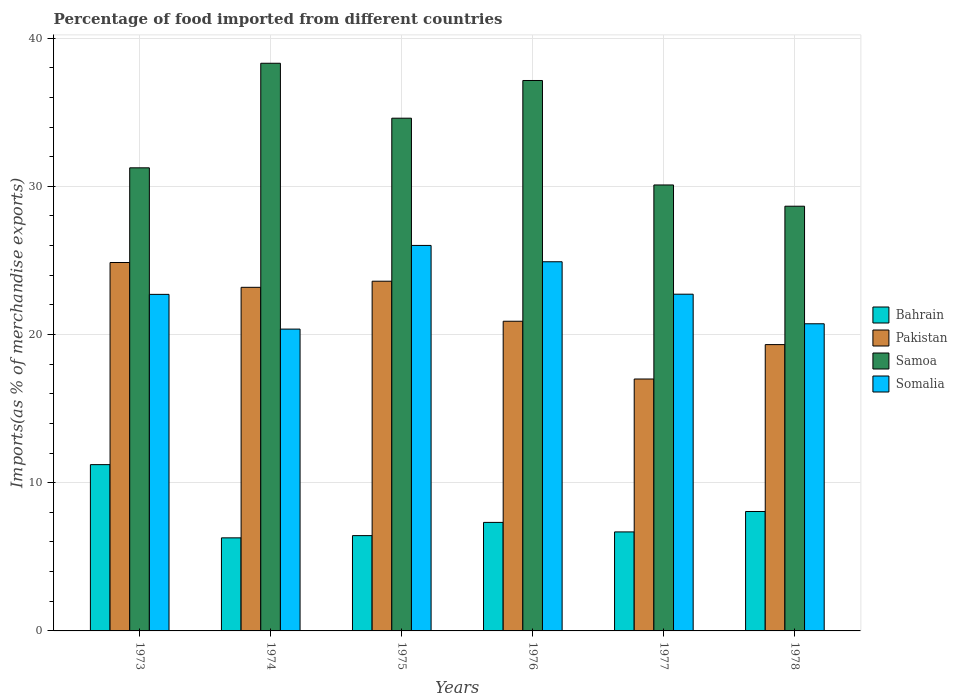How many groups of bars are there?
Offer a terse response. 6. How many bars are there on the 5th tick from the right?
Offer a very short reply. 4. What is the percentage of imports to different countries in Pakistan in 1977?
Make the answer very short. 17. Across all years, what is the maximum percentage of imports to different countries in Bahrain?
Offer a very short reply. 11.22. Across all years, what is the minimum percentage of imports to different countries in Pakistan?
Your answer should be very brief. 17. In which year was the percentage of imports to different countries in Samoa maximum?
Make the answer very short. 1974. In which year was the percentage of imports to different countries in Bahrain minimum?
Your response must be concise. 1974. What is the total percentage of imports to different countries in Somalia in the graph?
Provide a succinct answer. 137.44. What is the difference between the percentage of imports to different countries in Bahrain in 1977 and that in 1978?
Your answer should be very brief. -1.38. What is the difference between the percentage of imports to different countries in Samoa in 1974 and the percentage of imports to different countries in Pakistan in 1978?
Provide a succinct answer. 18.98. What is the average percentage of imports to different countries in Somalia per year?
Offer a very short reply. 22.91. In the year 1973, what is the difference between the percentage of imports to different countries in Pakistan and percentage of imports to different countries in Samoa?
Your answer should be very brief. -6.39. In how many years, is the percentage of imports to different countries in Bahrain greater than 16 %?
Make the answer very short. 0. What is the ratio of the percentage of imports to different countries in Somalia in 1974 to that in 1976?
Offer a very short reply. 0.82. What is the difference between the highest and the second highest percentage of imports to different countries in Bahrain?
Offer a terse response. 3.16. What is the difference between the highest and the lowest percentage of imports to different countries in Pakistan?
Ensure brevity in your answer.  7.86. In how many years, is the percentage of imports to different countries in Bahrain greater than the average percentage of imports to different countries in Bahrain taken over all years?
Make the answer very short. 2. Is it the case that in every year, the sum of the percentage of imports to different countries in Pakistan and percentage of imports to different countries in Somalia is greater than the sum of percentage of imports to different countries in Samoa and percentage of imports to different countries in Bahrain?
Offer a very short reply. No. What does the 3rd bar from the left in 1976 represents?
Offer a very short reply. Samoa. What does the 1st bar from the right in 1976 represents?
Your answer should be very brief. Somalia. How many bars are there?
Your response must be concise. 24. Are all the bars in the graph horizontal?
Offer a terse response. No. How many years are there in the graph?
Your answer should be compact. 6. What is the difference between two consecutive major ticks on the Y-axis?
Your answer should be compact. 10. Does the graph contain any zero values?
Offer a terse response. No. Does the graph contain grids?
Give a very brief answer. Yes. How many legend labels are there?
Ensure brevity in your answer.  4. How are the legend labels stacked?
Your response must be concise. Vertical. What is the title of the graph?
Ensure brevity in your answer.  Percentage of food imported from different countries. What is the label or title of the X-axis?
Offer a terse response. Years. What is the label or title of the Y-axis?
Offer a terse response. Imports(as % of merchandise exports). What is the Imports(as % of merchandise exports) in Bahrain in 1973?
Provide a short and direct response. 11.22. What is the Imports(as % of merchandise exports) in Pakistan in 1973?
Your response must be concise. 24.86. What is the Imports(as % of merchandise exports) in Samoa in 1973?
Offer a very short reply. 31.25. What is the Imports(as % of merchandise exports) in Somalia in 1973?
Ensure brevity in your answer.  22.71. What is the Imports(as % of merchandise exports) in Bahrain in 1974?
Give a very brief answer. 6.28. What is the Imports(as % of merchandise exports) in Pakistan in 1974?
Your response must be concise. 23.18. What is the Imports(as % of merchandise exports) of Samoa in 1974?
Your response must be concise. 38.3. What is the Imports(as % of merchandise exports) in Somalia in 1974?
Keep it short and to the point. 20.37. What is the Imports(as % of merchandise exports) of Bahrain in 1975?
Offer a very short reply. 6.43. What is the Imports(as % of merchandise exports) in Pakistan in 1975?
Offer a very short reply. 23.6. What is the Imports(as % of merchandise exports) of Samoa in 1975?
Provide a succinct answer. 34.6. What is the Imports(as % of merchandise exports) of Somalia in 1975?
Provide a short and direct response. 26.01. What is the Imports(as % of merchandise exports) of Bahrain in 1976?
Keep it short and to the point. 7.32. What is the Imports(as % of merchandise exports) in Pakistan in 1976?
Provide a succinct answer. 20.9. What is the Imports(as % of merchandise exports) of Samoa in 1976?
Provide a succinct answer. 37.14. What is the Imports(as % of merchandise exports) of Somalia in 1976?
Offer a very short reply. 24.91. What is the Imports(as % of merchandise exports) in Bahrain in 1977?
Offer a very short reply. 6.68. What is the Imports(as % of merchandise exports) of Pakistan in 1977?
Your answer should be very brief. 17. What is the Imports(as % of merchandise exports) in Samoa in 1977?
Your answer should be compact. 30.09. What is the Imports(as % of merchandise exports) of Somalia in 1977?
Provide a short and direct response. 22.72. What is the Imports(as % of merchandise exports) of Bahrain in 1978?
Offer a terse response. 8.06. What is the Imports(as % of merchandise exports) in Pakistan in 1978?
Provide a short and direct response. 19.32. What is the Imports(as % of merchandise exports) of Samoa in 1978?
Offer a terse response. 28.66. What is the Imports(as % of merchandise exports) in Somalia in 1978?
Keep it short and to the point. 20.72. Across all years, what is the maximum Imports(as % of merchandise exports) of Bahrain?
Offer a very short reply. 11.22. Across all years, what is the maximum Imports(as % of merchandise exports) in Pakistan?
Keep it short and to the point. 24.86. Across all years, what is the maximum Imports(as % of merchandise exports) of Samoa?
Ensure brevity in your answer.  38.3. Across all years, what is the maximum Imports(as % of merchandise exports) in Somalia?
Offer a very short reply. 26.01. Across all years, what is the minimum Imports(as % of merchandise exports) in Bahrain?
Provide a succinct answer. 6.28. Across all years, what is the minimum Imports(as % of merchandise exports) in Pakistan?
Provide a succinct answer. 17. Across all years, what is the minimum Imports(as % of merchandise exports) of Samoa?
Your answer should be compact. 28.66. Across all years, what is the minimum Imports(as % of merchandise exports) in Somalia?
Your answer should be very brief. 20.37. What is the total Imports(as % of merchandise exports) of Bahrain in the graph?
Offer a terse response. 45.99. What is the total Imports(as % of merchandise exports) of Pakistan in the graph?
Provide a short and direct response. 128.85. What is the total Imports(as % of merchandise exports) of Samoa in the graph?
Offer a very short reply. 200.04. What is the total Imports(as % of merchandise exports) of Somalia in the graph?
Your answer should be compact. 137.44. What is the difference between the Imports(as % of merchandise exports) in Bahrain in 1973 and that in 1974?
Ensure brevity in your answer.  4.94. What is the difference between the Imports(as % of merchandise exports) of Pakistan in 1973 and that in 1974?
Give a very brief answer. 1.67. What is the difference between the Imports(as % of merchandise exports) in Samoa in 1973 and that in 1974?
Your response must be concise. -7.06. What is the difference between the Imports(as % of merchandise exports) in Somalia in 1973 and that in 1974?
Provide a succinct answer. 2.34. What is the difference between the Imports(as % of merchandise exports) in Bahrain in 1973 and that in 1975?
Provide a short and direct response. 4.79. What is the difference between the Imports(as % of merchandise exports) in Pakistan in 1973 and that in 1975?
Offer a terse response. 1.26. What is the difference between the Imports(as % of merchandise exports) in Samoa in 1973 and that in 1975?
Provide a succinct answer. -3.35. What is the difference between the Imports(as % of merchandise exports) in Somalia in 1973 and that in 1975?
Provide a short and direct response. -3.3. What is the difference between the Imports(as % of merchandise exports) in Bahrain in 1973 and that in 1976?
Ensure brevity in your answer.  3.9. What is the difference between the Imports(as % of merchandise exports) in Pakistan in 1973 and that in 1976?
Your answer should be very brief. 3.96. What is the difference between the Imports(as % of merchandise exports) of Samoa in 1973 and that in 1976?
Keep it short and to the point. -5.89. What is the difference between the Imports(as % of merchandise exports) of Somalia in 1973 and that in 1976?
Offer a terse response. -2.2. What is the difference between the Imports(as % of merchandise exports) of Bahrain in 1973 and that in 1977?
Provide a short and direct response. 4.54. What is the difference between the Imports(as % of merchandise exports) in Pakistan in 1973 and that in 1977?
Give a very brief answer. 7.86. What is the difference between the Imports(as % of merchandise exports) of Samoa in 1973 and that in 1977?
Keep it short and to the point. 1.16. What is the difference between the Imports(as % of merchandise exports) of Somalia in 1973 and that in 1977?
Your answer should be very brief. -0.01. What is the difference between the Imports(as % of merchandise exports) of Bahrain in 1973 and that in 1978?
Give a very brief answer. 3.16. What is the difference between the Imports(as % of merchandise exports) of Pakistan in 1973 and that in 1978?
Your answer should be very brief. 5.54. What is the difference between the Imports(as % of merchandise exports) in Samoa in 1973 and that in 1978?
Your answer should be very brief. 2.59. What is the difference between the Imports(as % of merchandise exports) in Somalia in 1973 and that in 1978?
Offer a very short reply. 1.98. What is the difference between the Imports(as % of merchandise exports) of Bahrain in 1974 and that in 1975?
Ensure brevity in your answer.  -0.15. What is the difference between the Imports(as % of merchandise exports) of Pakistan in 1974 and that in 1975?
Provide a succinct answer. -0.41. What is the difference between the Imports(as % of merchandise exports) of Samoa in 1974 and that in 1975?
Offer a very short reply. 3.71. What is the difference between the Imports(as % of merchandise exports) of Somalia in 1974 and that in 1975?
Your answer should be very brief. -5.65. What is the difference between the Imports(as % of merchandise exports) in Bahrain in 1974 and that in 1976?
Your response must be concise. -1.04. What is the difference between the Imports(as % of merchandise exports) in Pakistan in 1974 and that in 1976?
Keep it short and to the point. 2.29. What is the difference between the Imports(as % of merchandise exports) of Samoa in 1974 and that in 1976?
Keep it short and to the point. 1.16. What is the difference between the Imports(as % of merchandise exports) in Somalia in 1974 and that in 1976?
Offer a very short reply. -4.54. What is the difference between the Imports(as % of merchandise exports) of Bahrain in 1974 and that in 1977?
Offer a very short reply. -0.4. What is the difference between the Imports(as % of merchandise exports) in Pakistan in 1974 and that in 1977?
Your response must be concise. 6.19. What is the difference between the Imports(as % of merchandise exports) of Samoa in 1974 and that in 1977?
Make the answer very short. 8.21. What is the difference between the Imports(as % of merchandise exports) in Somalia in 1974 and that in 1977?
Provide a short and direct response. -2.36. What is the difference between the Imports(as % of merchandise exports) in Bahrain in 1974 and that in 1978?
Ensure brevity in your answer.  -1.78. What is the difference between the Imports(as % of merchandise exports) in Pakistan in 1974 and that in 1978?
Offer a very short reply. 3.87. What is the difference between the Imports(as % of merchandise exports) of Samoa in 1974 and that in 1978?
Offer a very short reply. 9.65. What is the difference between the Imports(as % of merchandise exports) of Somalia in 1974 and that in 1978?
Make the answer very short. -0.36. What is the difference between the Imports(as % of merchandise exports) in Bahrain in 1975 and that in 1976?
Offer a very short reply. -0.89. What is the difference between the Imports(as % of merchandise exports) in Pakistan in 1975 and that in 1976?
Keep it short and to the point. 2.7. What is the difference between the Imports(as % of merchandise exports) in Samoa in 1975 and that in 1976?
Keep it short and to the point. -2.54. What is the difference between the Imports(as % of merchandise exports) in Somalia in 1975 and that in 1976?
Provide a short and direct response. 1.1. What is the difference between the Imports(as % of merchandise exports) of Bahrain in 1975 and that in 1977?
Offer a very short reply. -0.25. What is the difference between the Imports(as % of merchandise exports) in Pakistan in 1975 and that in 1977?
Make the answer very short. 6.6. What is the difference between the Imports(as % of merchandise exports) in Samoa in 1975 and that in 1977?
Make the answer very short. 4.5. What is the difference between the Imports(as % of merchandise exports) in Somalia in 1975 and that in 1977?
Make the answer very short. 3.29. What is the difference between the Imports(as % of merchandise exports) of Bahrain in 1975 and that in 1978?
Your answer should be very brief. -1.63. What is the difference between the Imports(as % of merchandise exports) in Pakistan in 1975 and that in 1978?
Offer a terse response. 4.28. What is the difference between the Imports(as % of merchandise exports) of Samoa in 1975 and that in 1978?
Ensure brevity in your answer.  5.94. What is the difference between the Imports(as % of merchandise exports) in Somalia in 1975 and that in 1978?
Ensure brevity in your answer.  5.29. What is the difference between the Imports(as % of merchandise exports) of Bahrain in 1976 and that in 1977?
Your answer should be compact. 0.64. What is the difference between the Imports(as % of merchandise exports) in Pakistan in 1976 and that in 1977?
Offer a terse response. 3.9. What is the difference between the Imports(as % of merchandise exports) of Samoa in 1976 and that in 1977?
Offer a very short reply. 7.05. What is the difference between the Imports(as % of merchandise exports) in Somalia in 1976 and that in 1977?
Ensure brevity in your answer.  2.19. What is the difference between the Imports(as % of merchandise exports) of Bahrain in 1976 and that in 1978?
Provide a short and direct response. -0.74. What is the difference between the Imports(as % of merchandise exports) in Pakistan in 1976 and that in 1978?
Your answer should be very brief. 1.58. What is the difference between the Imports(as % of merchandise exports) in Samoa in 1976 and that in 1978?
Your answer should be compact. 8.48. What is the difference between the Imports(as % of merchandise exports) of Somalia in 1976 and that in 1978?
Offer a terse response. 4.18. What is the difference between the Imports(as % of merchandise exports) in Bahrain in 1977 and that in 1978?
Provide a short and direct response. -1.38. What is the difference between the Imports(as % of merchandise exports) in Pakistan in 1977 and that in 1978?
Offer a terse response. -2.32. What is the difference between the Imports(as % of merchandise exports) in Samoa in 1977 and that in 1978?
Your answer should be very brief. 1.43. What is the difference between the Imports(as % of merchandise exports) of Somalia in 1977 and that in 1978?
Ensure brevity in your answer.  2. What is the difference between the Imports(as % of merchandise exports) in Bahrain in 1973 and the Imports(as % of merchandise exports) in Pakistan in 1974?
Ensure brevity in your answer.  -11.96. What is the difference between the Imports(as % of merchandise exports) in Bahrain in 1973 and the Imports(as % of merchandise exports) in Samoa in 1974?
Give a very brief answer. -27.08. What is the difference between the Imports(as % of merchandise exports) in Bahrain in 1973 and the Imports(as % of merchandise exports) in Somalia in 1974?
Make the answer very short. -9.14. What is the difference between the Imports(as % of merchandise exports) of Pakistan in 1973 and the Imports(as % of merchandise exports) of Samoa in 1974?
Give a very brief answer. -13.44. What is the difference between the Imports(as % of merchandise exports) in Pakistan in 1973 and the Imports(as % of merchandise exports) in Somalia in 1974?
Offer a very short reply. 4.49. What is the difference between the Imports(as % of merchandise exports) in Samoa in 1973 and the Imports(as % of merchandise exports) in Somalia in 1974?
Your answer should be compact. 10.88. What is the difference between the Imports(as % of merchandise exports) in Bahrain in 1973 and the Imports(as % of merchandise exports) in Pakistan in 1975?
Offer a terse response. -12.38. What is the difference between the Imports(as % of merchandise exports) of Bahrain in 1973 and the Imports(as % of merchandise exports) of Samoa in 1975?
Ensure brevity in your answer.  -23.37. What is the difference between the Imports(as % of merchandise exports) in Bahrain in 1973 and the Imports(as % of merchandise exports) in Somalia in 1975?
Offer a terse response. -14.79. What is the difference between the Imports(as % of merchandise exports) of Pakistan in 1973 and the Imports(as % of merchandise exports) of Samoa in 1975?
Your answer should be very brief. -9.74. What is the difference between the Imports(as % of merchandise exports) of Pakistan in 1973 and the Imports(as % of merchandise exports) of Somalia in 1975?
Your response must be concise. -1.15. What is the difference between the Imports(as % of merchandise exports) of Samoa in 1973 and the Imports(as % of merchandise exports) of Somalia in 1975?
Offer a very short reply. 5.24. What is the difference between the Imports(as % of merchandise exports) in Bahrain in 1973 and the Imports(as % of merchandise exports) in Pakistan in 1976?
Your answer should be compact. -9.67. What is the difference between the Imports(as % of merchandise exports) in Bahrain in 1973 and the Imports(as % of merchandise exports) in Samoa in 1976?
Keep it short and to the point. -25.92. What is the difference between the Imports(as % of merchandise exports) in Bahrain in 1973 and the Imports(as % of merchandise exports) in Somalia in 1976?
Offer a very short reply. -13.69. What is the difference between the Imports(as % of merchandise exports) of Pakistan in 1973 and the Imports(as % of merchandise exports) of Samoa in 1976?
Offer a very short reply. -12.28. What is the difference between the Imports(as % of merchandise exports) of Pakistan in 1973 and the Imports(as % of merchandise exports) of Somalia in 1976?
Offer a terse response. -0.05. What is the difference between the Imports(as % of merchandise exports) in Samoa in 1973 and the Imports(as % of merchandise exports) in Somalia in 1976?
Offer a terse response. 6.34. What is the difference between the Imports(as % of merchandise exports) in Bahrain in 1973 and the Imports(as % of merchandise exports) in Pakistan in 1977?
Offer a very short reply. -5.78. What is the difference between the Imports(as % of merchandise exports) of Bahrain in 1973 and the Imports(as % of merchandise exports) of Samoa in 1977?
Ensure brevity in your answer.  -18.87. What is the difference between the Imports(as % of merchandise exports) of Bahrain in 1973 and the Imports(as % of merchandise exports) of Somalia in 1977?
Your response must be concise. -11.5. What is the difference between the Imports(as % of merchandise exports) in Pakistan in 1973 and the Imports(as % of merchandise exports) in Samoa in 1977?
Offer a very short reply. -5.23. What is the difference between the Imports(as % of merchandise exports) in Pakistan in 1973 and the Imports(as % of merchandise exports) in Somalia in 1977?
Keep it short and to the point. 2.14. What is the difference between the Imports(as % of merchandise exports) of Samoa in 1973 and the Imports(as % of merchandise exports) of Somalia in 1977?
Provide a succinct answer. 8.53. What is the difference between the Imports(as % of merchandise exports) of Bahrain in 1973 and the Imports(as % of merchandise exports) of Pakistan in 1978?
Your answer should be compact. -8.1. What is the difference between the Imports(as % of merchandise exports) in Bahrain in 1973 and the Imports(as % of merchandise exports) in Samoa in 1978?
Your answer should be very brief. -17.44. What is the difference between the Imports(as % of merchandise exports) of Bahrain in 1973 and the Imports(as % of merchandise exports) of Somalia in 1978?
Your response must be concise. -9.5. What is the difference between the Imports(as % of merchandise exports) of Pakistan in 1973 and the Imports(as % of merchandise exports) of Samoa in 1978?
Provide a succinct answer. -3.8. What is the difference between the Imports(as % of merchandise exports) of Pakistan in 1973 and the Imports(as % of merchandise exports) of Somalia in 1978?
Provide a short and direct response. 4.13. What is the difference between the Imports(as % of merchandise exports) in Samoa in 1973 and the Imports(as % of merchandise exports) in Somalia in 1978?
Keep it short and to the point. 10.52. What is the difference between the Imports(as % of merchandise exports) in Bahrain in 1974 and the Imports(as % of merchandise exports) in Pakistan in 1975?
Your answer should be very brief. -17.32. What is the difference between the Imports(as % of merchandise exports) of Bahrain in 1974 and the Imports(as % of merchandise exports) of Samoa in 1975?
Ensure brevity in your answer.  -28.32. What is the difference between the Imports(as % of merchandise exports) in Bahrain in 1974 and the Imports(as % of merchandise exports) in Somalia in 1975?
Ensure brevity in your answer.  -19.73. What is the difference between the Imports(as % of merchandise exports) in Pakistan in 1974 and the Imports(as % of merchandise exports) in Samoa in 1975?
Your answer should be very brief. -11.41. What is the difference between the Imports(as % of merchandise exports) of Pakistan in 1974 and the Imports(as % of merchandise exports) of Somalia in 1975?
Offer a terse response. -2.83. What is the difference between the Imports(as % of merchandise exports) in Samoa in 1974 and the Imports(as % of merchandise exports) in Somalia in 1975?
Ensure brevity in your answer.  12.29. What is the difference between the Imports(as % of merchandise exports) of Bahrain in 1974 and the Imports(as % of merchandise exports) of Pakistan in 1976?
Keep it short and to the point. -14.62. What is the difference between the Imports(as % of merchandise exports) in Bahrain in 1974 and the Imports(as % of merchandise exports) in Samoa in 1976?
Ensure brevity in your answer.  -30.86. What is the difference between the Imports(as % of merchandise exports) in Bahrain in 1974 and the Imports(as % of merchandise exports) in Somalia in 1976?
Offer a very short reply. -18.63. What is the difference between the Imports(as % of merchandise exports) of Pakistan in 1974 and the Imports(as % of merchandise exports) of Samoa in 1976?
Provide a succinct answer. -13.96. What is the difference between the Imports(as % of merchandise exports) in Pakistan in 1974 and the Imports(as % of merchandise exports) in Somalia in 1976?
Give a very brief answer. -1.72. What is the difference between the Imports(as % of merchandise exports) in Samoa in 1974 and the Imports(as % of merchandise exports) in Somalia in 1976?
Your answer should be very brief. 13.39. What is the difference between the Imports(as % of merchandise exports) in Bahrain in 1974 and the Imports(as % of merchandise exports) in Pakistan in 1977?
Provide a short and direct response. -10.72. What is the difference between the Imports(as % of merchandise exports) of Bahrain in 1974 and the Imports(as % of merchandise exports) of Samoa in 1977?
Provide a succinct answer. -23.81. What is the difference between the Imports(as % of merchandise exports) in Bahrain in 1974 and the Imports(as % of merchandise exports) in Somalia in 1977?
Make the answer very short. -16.44. What is the difference between the Imports(as % of merchandise exports) of Pakistan in 1974 and the Imports(as % of merchandise exports) of Samoa in 1977?
Your answer should be very brief. -6.91. What is the difference between the Imports(as % of merchandise exports) of Pakistan in 1974 and the Imports(as % of merchandise exports) of Somalia in 1977?
Offer a terse response. 0.46. What is the difference between the Imports(as % of merchandise exports) of Samoa in 1974 and the Imports(as % of merchandise exports) of Somalia in 1977?
Provide a short and direct response. 15.58. What is the difference between the Imports(as % of merchandise exports) in Bahrain in 1974 and the Imports(as % of merchandise exports) in Pakistan in 1978?
Offer a terse response. -13.04. What is the difference between the Imports(as % of merchandise exports) of Bahrain in 1974 and the Imports(as % of merchandise exports) of Samoa in 1978?
Your answer should be compact. -22.38. What is the difference between the Imports(as % of merchandise exports) of Bahrain in 1974 and the Imports(as % of merchandise exports) of Somalia in 1978?
Ensure brevity in your answer.  -14.45. What is the difference between the Imports(as % of merchandise exports) in Pakistan in 1974 and the Imports(as % of merchandise exports) in Samoa in 1978?
Make the answer very short. -5.47. What is the difference between the Imports(as % of merchandise exports) in Pakistan in 1974 and the Imports(as % of merchandise exports) in Somalia in 1978?
Ensure brevity in your answer.  2.46. What is the difference between the Imports(as % of merchandise exports) of Samoa in 1974 and the Imports(as % of merchandise exports) of Somalia in 1978?
Offer a terse response. 17.58. What is the difference between the Imports(as % of merchandise exports) in Bahrain in 1975 and the Imports(as % of merchandise exports) in Pakistan in 1976?
Provide a short and direct response. -14.47. What is the difference between the Imports(as % of merchandise exports) in Bahrain in 1975 and the Imports(as % of merchandise exports) in Samoa in 1976?
Your answer should be very brief. -30.71. What is the difference between the Imports(as % of merchandise exports) of Bahrain in 1975 and the Imports(as % of merchandise exports) of Somalia in 1976?
Make the answer very short. -18.48. What is the difference between the Imports(as % of merchandise exports) of Pakistan in 1975 and the Imports(as % of merchandise exports) of Samoa in 1976?
Offer a very short reply. -13.54. What is the difference between the Imports(as % of merchandise exports) of Pakistan in 1975 and the Imports(as % of merchandise exports) of Somalia in 1976?
Offer a terse response. -1.31. What is the difference between the Imports(as % of merchandise exports) of Samoa in 1975 and the Imports(as % of merchandise exports) of Somalia in 1976?
Make the answer very short. 9.69. What is the difference between the Imports(as % of merchandise exports) in Bahrain in 1975 and the Imports(as % of merchandise exports) in Pakistan in 1977?
Offer a terse response. -10.57. What is the difference between the Imports(as % of merchandise exports) in Bahrain in 1975 and the Imports(as % of merchandise exports) in Samoa in 1977?
Provide a succinct answer. -23.66. What is the difference between the Imports(as % of merchandise exports) in Bahrain in 1975 and the Imports(as % of merchandise exports) in Somalia in 1977?
Your response must be concise. -16.29. What is the difference between the Imports(as % of merchandise exports) of Pakistan in 1975 and the Imports(as % of merchandise exports) of Samoa in 1977?
Offer a terse response. -6.49. What is the difference between the Imports(as % of merchandise exports) of Pakistan in 1975 and the Imports(as % of merchandise exports) of Somalia in 1977?
Provide a short and direct response. 0.88. What is the difference between the Imports(as % of merchandise exports) of Samoa in 1975 and the Imports(as % of merchandise exports) of Somalia in 1977?
Your answer should be compact. 11.88. What is the difference between the Imports(as % of merchandise exports) of Bahrain in 1975 and the Imports(as % of merchandise exports) of Pakistan in 1978?
Make the answer very short. -12.89. What is the difference between the Imports(as % of merchandise exports) of Bahrain in 1975 and the Imports(as % of merchandise exports) of Samoa in 1978?
Your answer should be very brief. -22.23. What is the difference between the Imports(as % of merchandise exports) in Bahrain in 1975 and the Imports(as % of merchandise exports) in Somalia in 1978?
Provide a short and direct response. -14.29. What is the difference between the Imports(as % of merchandise exports) in Pakistan in 1975 and the Imports(as % of merchandise exports) in Samoa in 1978?
Offer a very short reply. -5.06. What is the difference between the Imports(as % of merchandise exports) of Pakistan in 1975 and the Imports(as % of merchandise exports) of Somalia in 1978?
Make the answer very short. 2.87. What is the difference between the Imports(as % of merchandise exports) of Samoa in 1975 and the Imports(as % of merchandise exports) of Somalia in 1978?
Make the answer very short. 13.87. What is the difference between the Imports(as % of merchandise exports) in Bahrain in 1976 and the Imports(as % of merchandise exports) in Pakistan in 1977?
Provide a succinct answer. -9.67. What is the difference between the Imports(as % of merchandise exports) in Bahrain in 1976 and the Imports(as % of merchandise exports) in Samoa in 1977?
Offer a very short reply. -22.77. What is the difference between the Imports(as % of merchandise exports) of Bahrain in 1976 and the Imports(as % of merchandise exports) of Somalia in 1977?
Offer a terse response. -15.4. What is the difference between the Imports(as % of merchandise exports) in Pakistan in 1976 and the Imports(as % of merchandise exports) in Samoa in 1977?
Your answer should be very brief. -9.2. What is the difference between the Imports(as % of merchandise exports) in Pakistan in 1976 and the Imports(as % of merchandise exports) in Somalia in 1977?
Give a very brief answer. -1.82. What is the difference between the Imports(as % of merchandise exports) in Samoa in 1976 and the Imports(as % of merchandise exports) in Somalia in 1977?
Offer a terse response. 14.42. What is the difference between the Imports(as % of merchandise exports) in Bahrain in 1976 and the Imports(as % of merchandise exports) in Pakistan in 1978?
Your answer should be compact. -12. What is the difference between the Imports(as % of merchandise exports) of Bahrain in 1976 and the Imports(as % of merchandise exports) of Samoa in 1978?
Your response must be concise. -21.33. What is the difference between the Imports(as % of merchandise exports) of Bahrain in 1976 and the Imports(as % of merchandise exports) of Somalia in 1978?
Provide a short and direct response. -13.4. What is the difference between the Imports(as % of merchandise exports) in Pakistan in 1976 and the Imports(as % of merchandise exports) in Samoa in 1978?
Make the answer very short. -7.76. What is the difference between the Imports(as % of merchandise exports) of Pakistan in 1976 and the Imports(as % of merchandise exports) of Somalia in 1978?
Provide a succinct answer. 0.17. What is the difference between the Imports(as % of merchandise exports) of Samoa in 1976 and the Imports(as % of merchandise exports) of Somalia in 1978?
Give a very brief answer. 16.42. What is the difference between the Imports(as % of merchandise exports) in Bahrain in 1977 and the Imports(as % of merchandise exports) in Pakistan in 1978?
Keep it short and to the point. -12.64. What is the difference between the Imports(as % of merchandise exports) in Bahrain in 1977 and the Imports(as % of merchandise exports) in Samoa in 1978?
Provide a succinct answer. -21.98. What is the difference between the Imports(as % of merchandise exports) of Bahrain in 1977 and the Imports(as % of merchandise exports) of Somalia in 1978?
Make the answer very short. -14.04. What is the difference between the Imports(as % of merchandise exports) in Pakistan in 1977 and the Imports(as % of merchandise exports) in Samoa in 1978?
Ensure brevity in your answer.  -11.66. What is the difference between the Imports(as % of merchandise exports) in Pakistan in 1977 and the Imports(as % of merchandise exports) in Somalia in 1978?
Your answer should be compact. -3.73. What is the difference between the Imports(as % of merchandise exports) of Samoa in 1977 and the Imports(as % of merchandise exports) of Somalia in 1978?
Offer a very short reply. 9.37. What is the average Imports(as % of merchandise exports) in Bahrain per year?
Make the answer very short. 7.67. What is the average Imports(as % of merchandise exports) in Pakistan per year?
Offer a very short reply. 21.48. What is the average Imports(as % of merchandise exports) in Samoa per year?
Your response must be concise. 33.34. What is the average Imports(as % of merchandise exports) in Somalia per year?
Give a very brief answer. 22.91. In the year 1973, what is the difference between the Imports(as % of merchandise exports) of Bahrain and Imports(as % of merchandise exports) of Pakistan?
Give a very brief answer. -13.64. In the year 1973, what is the difference between the Imports(as % of merchandise exports) in Bahrain and Imports(as % of merchandise exports) in Samoa?
Offer a terse response. -20.03. In the year 1973, what is the difference between the Imports(as % of merchandise exports) of Bahrain and Imports(as % of merchandise exports) of Somalia?
Your answer should be very brief. -11.49. In the year 1973, what is the difference between the Imports(as % of merchandise exports) of Pakistan and Imports(as % of merchandise exports) of Samoa?
Provide a succinct answer. -6.39. In the year 1973, what is the difference between the Imports(as % of merchandise exports) of Pakistan and Imports(as % of merchandise exports) of Somalia?
Your answer should be compact. 2.15. In the year 1973, what is the difference between the Imports(as % of merchandise exports) in Samoa and Imports(as % of merchandise exports) in Somalia?
Ensure brevity in your answer.  8.54. In the year 1974, what is the difference between the Imports(as % of merchandise exports) of Bahrain and Imports(as % of merchandise exports) of Pakistan?
Your answer should be compact. -16.91. In the year 1974, what is the difference between the Imports(as % of merchandise exports) of Bahrain and Imports(as % of merchandise exports) of Samoa?
Make the answer very short. -32.02. In the year 1974, what is the difference between the Imports(as % of merchandise exports) of Bahrain and Imports(as % of merchandise exports) of Somalia?
Keep it short and to the point. -14.09. In the year 1974, what is the difference between the Imports(as % of merchandise exports) of Pakistan and Imports(as % of merchandise exports) of Samoa?
Make the answer very short. -15.12. In the year 1974, what is the difference between the Imports(as % of merchandise exports) in Pakistan and Imports(as % of merchandise exports) in Somalia?
Provide a short and direct response. 2.82. In the year 1974, what is the difference between the Imports(as % of merchandise exports) of Samoa and Imports(as % of merchandise exports) of Somalia?
Offer a terse response. 17.94. In the year 1975, what is the difference between the Imports(as % of merchandise exports) in Bahrain and Imports(as % of merchandise exports) in Pakistan?
Give a very brief answer. -17.17. In the year 1975, what is the difference between the Imports(as % of merchandise exports) of Bahrain and Imports(as % of merchandise exports) of Samoa?
Keep it short and to the point. -28.17. In the year 1975, what is the difference between the Imports(as % of merchandise exports) of Bahrain and Imports(as % of merchandise exports) of Somalia?
Give a very brief answer. -19.58. In the year 1975, what is the difference between the Imports(as % of merchandise exports) of Pakistan and Imports(as % of merchandise exports) of Samoa?
Give a very brief answer. -11. In the year 1975, what is the difference between the Imports(as % of merchandise exports) in Pakistan and Imports(as % of merchandise exports) in Somalia?
Your response must be concise. -2.41. In the year 1975, what is the difference between the Imports(as % of merchandise exports) in Samoa and Imports(as % of merchandise exports) in Somalia?
Provide a short and direct response. 8.58. In the year 1976, what is the difference between the Imports(as % of merchandise exports) in Bahrain and Imports(as % of merchandise exports) in Pakistan?
Make the answer very short. -13.57. In the year 1976, what is the difference between the Imports(as % of merchandise exports) of Bahrain and Imports(as % of merchandise exports) of Samoa?
Offer a terse response. -29.82. In the year 1976, what is the difference between the Imports(as % of merchandise exports) of Bahrain and Imports(as % of merchandise exports) of Somalia?
Ensure brevity in your answer.  -17.59. In the year 1976, what is the difference between the Imports(as % of merchandise exports) of Pakistan and Imports(as % of merchandise exports) of Samoa?
Your response must be concise. -16.24. In the year 1976, what is the difference between the Imports(as % of merchandise exports) of Pakistan and Imports(as % of merchandise exports) of Somalia?
Ensure brevity in your answer.  -4.01. In the year 1976, what is the difference between the Imports(as % of merchandise exports) in Samoa and Imports(as % of merchandise exports) in Somalia?
Offer a very short reply. 12.23. In the year 1977, what is the difference between the Imports(as % of merchandise exports) in Bahrain and Imports(as % of merchandise exports) in Pakistan?
Offer a terse response. -10.32. In the year 1977, what is the difference between the Imports(as % of merchandise exports) in Bahrain and Imports(as % of merchandise exports) in Samoa?
Make the answer very short. -23.41. In the year 1977, what is the difference between the Imports(as % of merchandise exports) of Bahrain and Imports(as % of merchandise exports) of Somalia?
Give a very brief answer. -16.04. In the year 1977, what is the difference between the Imports(as % of merchandise exports) of Pakistan and Imports(as % of merchandise exports) of Samoa?
Give a very brief answer. -13.09. In the year 1977, what is the difference between the Imports(as % of merchandise exports) in Pakistan and Imports(as % of merchandise exports) in Somalia?
Give a very brief answer. -5.72. In the year 1977, what is the difference between the Imports(as % of merchandise exports) of Samoa and Imports(as % of merchandise exports) of Somalia?
Provide a succinct answer. 7.37. In the year 1978, what is the difference between the Imports(as % of merchandise exports) of Bahrain and Imports(as % of merchandise exports) of Pakistan?
Keep it short and to the point. -11.26. In the year 1978, what is the difference between the Imports(as % of merchandise exports) in Bahrain and Imports(as % of merchandise exports) in Samoa?
Your answer should be compact. -20.6. In the year 1978, what is the difference between the Imports(as % of merchandise exports) in Bahrain and Imports(as % of merchandise exports) in Somalia?
Provide a succinct answer. -12.67. In the year 1978, what is the difference between the Imports(as % of merchandise exports) of Pakistan and Imports(as % of merchandise exports) of Samoa?
Provide a short and direct response. -9.34. In the year 1978, what is the difference between the Imports(as % of merchandise exports) of Pakistan and Imports(as % of merchandise exports) of Somalia?
Offer a terse response. -1.41. In the year 1978, what is the difference between the Imports(as % of merchandise exports) of Samoa and Imports(as % of merchandise exports) of Somalia?
Your answer should be compact. 7.93. What is the ratio of the Imports(as % of merchandise exports) in Bahrain in 1973 to that in 1974?
Ensure brevity in your answer.  1.79. What is the ratio of the Imports(as % of merchandise exports) in Pakistan in 1973 to that in 1974?
Provide a short and direct response. 1.07. What is the ratio of the Imports(as % of merchandise exports) in Samoa in 1973 to that in 1974?
Provide a short and direct response. 0.82. What is the ratio of the Imports(as % of merchandise exports) in Somalia in 1973 to that in 1974?
Ensure brevity in your answer.  1.12. What is the ratio of the Imports(as % of merchandise exports) in Bahrain in 1973 to that in 1975?
Offer a terse response. 1.75. What is the ratio of the Imports(as % of merchandise exports) in Pakistan in 1973 to that in 1975?
Provide a succinct answer. 1.05. What is the ratio of the Imports(as % of merchandise exports) in Samoa in 1973 to that in 1975?
Ensure brevity in your answer.  0.9. What is the ratio of the Imports(as % of merchandise exports) of Somalia in 1973 to that in 1975?
Provide a short and direct response. 0.87. What is the ratio of the Imports(as % of merchandise exports) in Bahrain in 1973 to that in 1976?
Your answer should be compact. 1.53. What is the ratio of the Imports(as % of merchandise exports) of Pakistan in 1973 to that in 1976?
Ensure brevity in your answer.  1.19. What is the ratio of the Imports(as % of merchandise exports) in Samoa in 1973 to that in 1976?
Make the answer very short. 0.84. What is the ratio of the Imports(as % of merchandise exports) of Somalia in 1973 to that in 1976?
Make the answer very short. 0.91. What is the ratio of the Imports(as % of merchandise exports) in Bahrain in 1973 to that in 1977?
Your answer should be very brief. 1.68. What is the ratio of the Imports(as % of merchandise exports) in Pakistan in 1973 to that in 1977?
Ensure brevity in your answer.  1.46. What is the ratio of the Imports(as % of merchandise exports) of Samoa in 1973 to that in 1977?
Offer a terse response. 1.04. What is the ratio of the Imports(as % of merchandise exports) in Bahrain in 1973 to that in 1978?
Provide a short and direct response. 1.39. What is the ratio of the Imports(as % of merchandise exports) in Pakistan in 1973 to that in 1978?
Your answer should be very brief. 1.29. What is the ratio of the Imports(as % of merchandise exports) of Samoa in 1973 to that in 1978?
Your answer should be compact. 1.09. What is the ratio of the Imports(as % of merchandise exports) of Somalia in 1973 to that in 1978?
Your answer should be compact. 1.1. What is the ratio of the Imports(as % of merchandise exports) of Bahrain in 1974 to that in 1975?
Your answer should be compact. 0.98. What is the ratio of the Imports(as % of merchandise exports) in Pakistan in 1974 to that in 1975?
Offer a terse response. 0.98. What is the ratio of the Imports(as % of merchandise exports) in Samoa in 1974 to that in 1975?
Your answer should be compact. 1.11. What is the ratio of the Imports(as % of merchandise exports) in Somalia in 1974 to that in 1975?
Ensure brevity in your answer.  0.78. What is the ratio of the Imports(as % of merchandise exports) in Bahrain in 1974 to that in 1976?
Offer a very short reply. 0.86. What is the ratio of the Imports(as % of merchandise exports) in Pakistan in 1974 to that in 1976?
Your response must be concise. 1.11. What is the ratio of the Imports(as % of merchandise exports) of Samoa in 1974 to that in 1976?
Provide a short and direct response. 1.03. What is the ratio of the Imports(as % of merchandise exports) in Somalia in 1974 to that in 1976?
Your answer should be compact. 0.82. What is the ratio of the Imports(as % of merchandise exports) in Bahrain in 1974 to that in 1977?
Your response must be concise. 0.94. What is the ratio of the Imports(as % of merchandise exports) in Pakistan in 1974 to that in 1977?
Offer a very short reply. 1.36. What is the ratio of the Imports(as % of merchandise exports) in Samoa in 1974 to that in 1977?
Keep it short and to the point. 1.27. What is the ratio of the Imports(as % of merchandise exports) of Somalia in 1974 to that in 1977?
Offer a very short reply. 0.9. What is the ratio of the Imports(as % of merchandise exports) in Bahrain in 1974 to that in 1978?
Your answer should be compact. 0.78. What is the ratio of the Imports(as % of merchandise exports) of Pakistan in 1974 to that in 1978?
Make the answer very short. 1.2. What is the ratio of the Imports(as % of merchandise exports) of Samoa in 1974 to that in 1978?
Offer a terse response. 1.34. What is the ratio of the Imports(as % of merchandise exports) of Somalia in 1974 to that in 1978?
Make the answer very short. 0.98. What is the ratio of the Imports(as % of merchandise exports) of Bahrain in 1975 to that in 1976?
Your answer should be compact. 0.88. What is the ratio of the Imports(as % of merchandise exports) in Pakistan in 1975 to that in 1976?
Ensure brevity in your answer.  1.13. What is the ratio of the Imports(as % of merchandise exports) in Samoa in 1975 to that in 1976?
Make the answer very short. 0.93. What is the ratio of the Imports(as % of merchandise exports) of Somalia in 1975 to that in 1976?
Provide a succinct answer. 1.04. What is the ratio of the Imports(as % of merchandise exports) of Bahrain in 1975 to that in 1977?
Make the answer very short. 0.96. What is the ratio of the Imports(as % of merchandise exports) in Pakistan in 1975 to that in 1977?
Your answer should be compact. 1.39. What is the ratio of the Imports(as % of merchandise exports) in Samoa in 1975 to that in 1977?
Give a very brief answer. 1.15. What is the ratio of the Imports(as % of merchandise exports) in Somalia in 1975 to that in 1977?
Keep it short and to the point. 1.14. What is the ratio of the Imports(as % of merchandise exports) in Bahrain in 1975 to that in 1978?
Ensure brevity in your answer.  0.8. What is the ratio of the Imports(as % of merchandise exports) in Pakistan in 1975 to that in 1978?
Provide a succinct answer. 1.22. What is the ratio of the Imports(as % of merchandise exports) in Samoa in 1975 to that in 1978?
Ensure brevity in your answer.  1.21. What is the ratio of the Imports(as % of merchandise exports) in Somalia in 1975 to that in 1978?
Give a very brief answer. 1.25. What is the ratio of the Imports(as % of merchandise exports) of Bahrain in 1976 to that in 1977?
Provide a succinct answer. 1.1. What is the ratio of the Imports(as % of merchandise exports) of Pakistan in 1976 to that in 1977?
Make the answer very short. 1.23. What is the ratio of the Imports(as % of merchandise exports) of Samoa in 1976 to that in 1977?
Make the answer very short. 1.23. What is the ratio of the Imports(as % of merchandise exports) in Somalia in 1976 to that in 1977?
Your answer should be very brief. 1.1. What is the ratio of the Imports(as % of merchandise exports) in Bahrain in 1976 to that in 1978?
Your answer should be very brief. 0.91. What is the ratio of the Imports(as % of merchandise exports) in Pakistan in 1976 to that in 1978?
Your answer should be compact. 1.08. What is the ratio of the Imports(as % of merchandise exports) in Samoa in 1976 to that in 1978?
Provide a succinct answer. 1.3. What is the ratio of the Imports(as % of merchandise exports) in Somalia in 1976 to that in 1978?
Your answer should be very brief. 1.2. What is the ratio of the Imports(as % of merchandise exports) in Bahrain in 1977 to that in 1978?
Your response must be concise. 0.83. What is the ratio of the Imports(as % of merchandise exports) of Pakistan in 1977 to that in 1978?
Offer a very short reply. 0.88. What is the ratio of the Imports(as % of merchandise exports) of Somalia in 1977 to that in 1978?
Your response must be concise. 1.1. What is the difference between the highest and the second highest Imports(as % of merchandise exports) of Bahrain?
Your response must be concise. 3.16. What is the difference between the highest and the second highest Imports(as % of merchandise exports) of Pakistan?
Your response must be concise. 1.26. What is the difference between the highest and the second highest Imports(as % of merchandise exports) in Samoa?
Your answer should be compact. 1.16. What is the difference between the highest and the second highest Imports(as % of merchandise exports) in Somalia?
Give a very brief answer. 1.1. What is the difference between the highest and the lowest Imports(as % of merchandise exports) in Bahrain?
Offer a terse response. 4.94. What is the difference between the highest and the lowest Imports(as % of merchandise exports) in Pakistan?
Give a very brief answer. 7.86. What is the difference between the highest and the lowest Imports(as % of merchandise exports) of Samoa?
Provide a short and direct response. 9.65. What is the difference between the highest and the lowest Imports(as % of merchandise exports) of Somalia?
Your answer should be very brief. 5.65. 